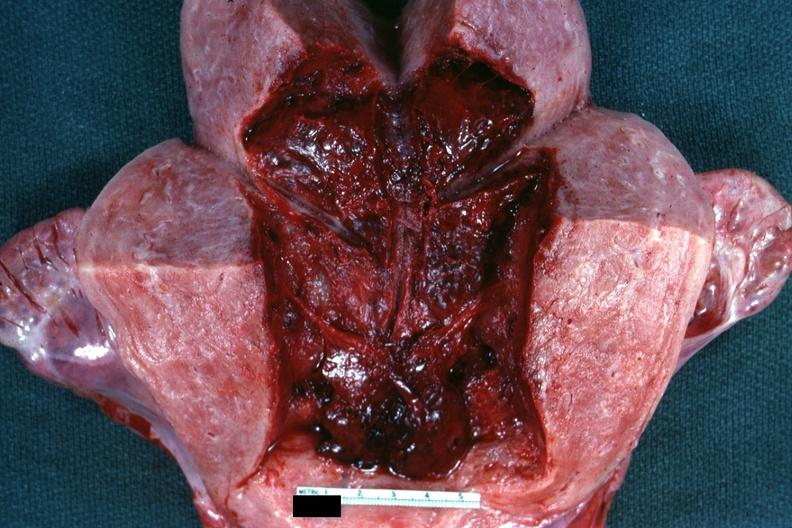s uterus present?
Answer the question using a single word or phrase. Yes 